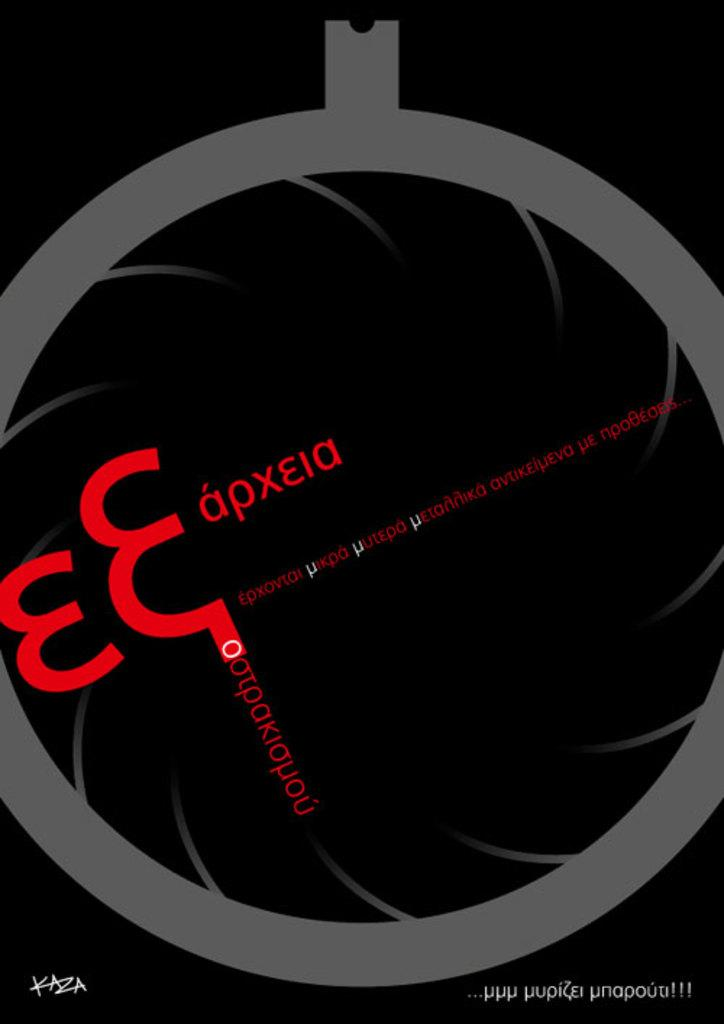<image>
Present a compact description of the photo's key features. A black poster with red Russian lettering written horizontally across the center. 